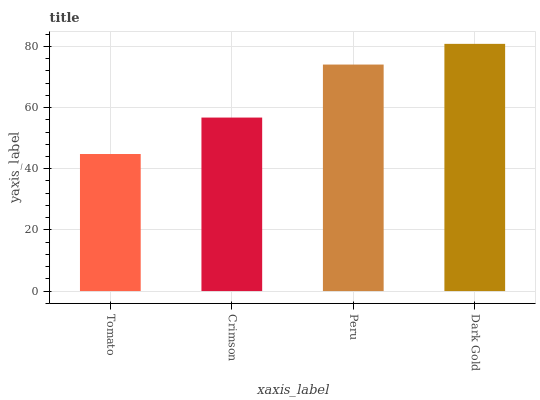Is Tomato the minimum?
Answer yes or no. Yes. Is Dark Gold the maximum?
Answer yes or no. Yes. Is Crimson the minimum?
Answer yes or no. No. Is Crimson the maximum?
Answer yes or no. No. Is Crimson greater than Tomato?
Answer yes or no. Yes. Is Tomato less than Crimson?
Answer yes or no. Yes. Is Tomato greater than Crimson?
Answer yes or no. No. Is Crimson less than Tomato?
Answer yes or no. No. Is Peru the high median?
Answer yes or no. Yes. Is Crimson the low median?
Answer yes or no. Yes. Is Tomato the high median?
Answer yes or no. No. Is Dark Gold the low median?
Answer yes or no. No. 